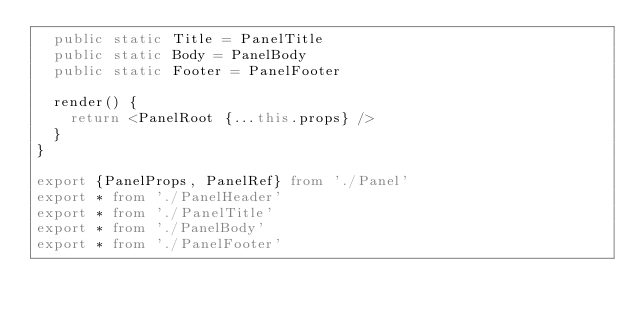<code> <loc_0><loc_0><loc_500><loc_500><_TypeScript_>  public static Title = PanelTitle
  public static Body = PanelBody
  public static Footer = PanelFooter

  render() {
    return <PanelRoot {...this.props} />
  }
}

export {PanelProps, PanelRef} from './Panel'
export * from './PanelHeader'
export * from './PanelTitle'
export * from './PanelBody'
export * from './PanelFooter'
</code> 